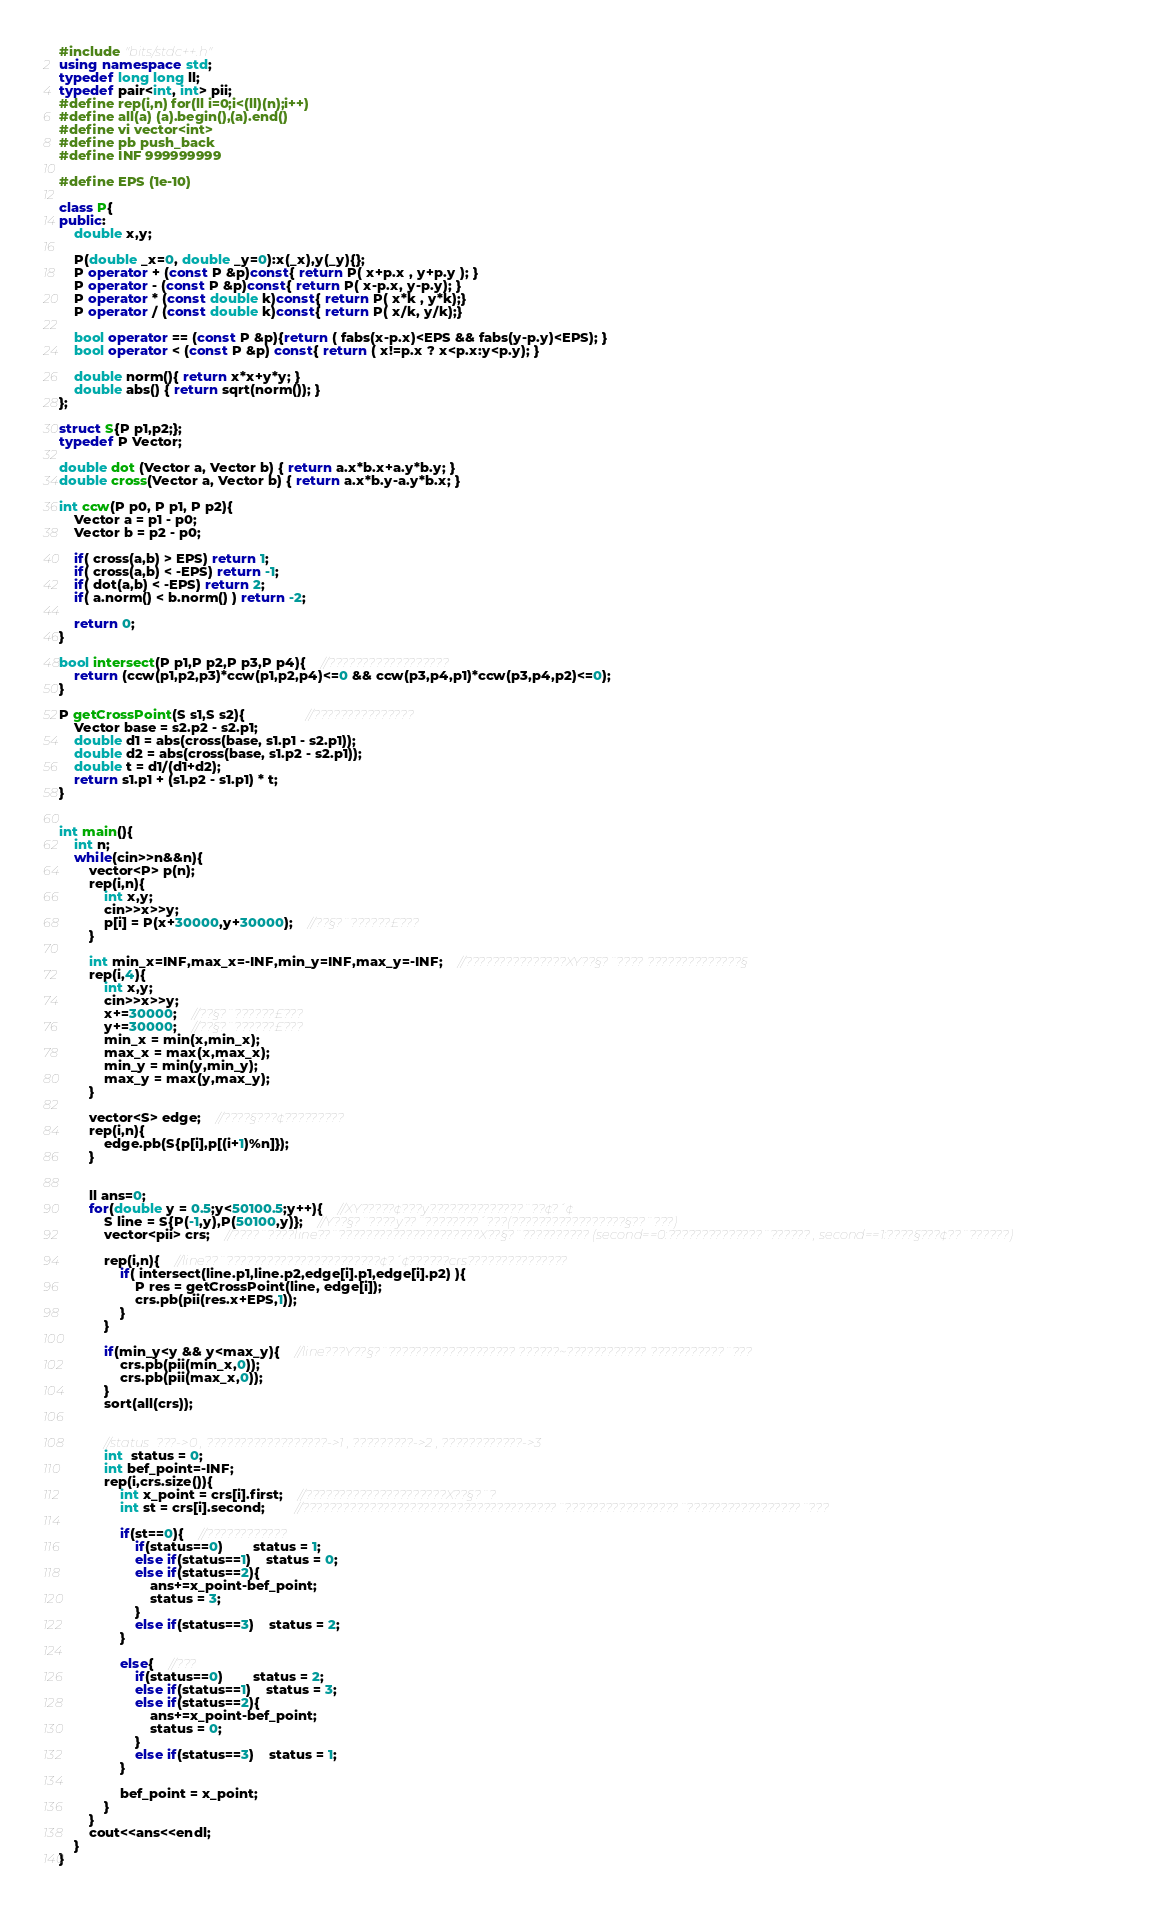<code> <loc_0><loc_0><loc_500><loc_500><_C++_>#include "bits/stdc++.h"
using namespace std;
typedef long long ll;
typedef pair<int, int> pii;
#define rep(i,n) for(ll i=0;i<(ll)(n);i++)
#define all(a) (a).begin(),(a).end()
#define vi vector<int>
#define pb push_back
#define INF 999999999

#define EPS (1e-10)

class P{
public:
	double x,y;
	
	P(double _x=0, double _y=0):x(_x),y(_y){};
	P operator + (const P &p)const{ return P( x+p.x , y+p.y ); }
	P operator - (const P &p)const{ return P( x-p.x, y-p.y); }
	P operator * (const double k)const{ return P( x*k , y*k);}
	P operator / (const double k)const{ return P( x/k, y/k);}
	
	bool operator == (const P &p){return ( fabs(x-p.x)<EPS && fabs(y-p.y)<EPS); }
	bool operator < (const P &p) const{ return ( x!=p.x ? x<p.x:y<p.y); }
	
	double norm(){ return x*x+y*y; }
	double abs() { return sqrt(norm()); }
};

struct S{P p1,p2;};
typedef P Vector;

double dot (Vector a, Vector b) { return a.x*b.x+a.y*b.y; }
double cross(Vector a, Vector b) { return a.x*b.y-a.y*b.x; }

int ccw(P p0, P p1, P p2){
	Vector a = p1 - p0;
	Vector b = p2 - p0;
	
	if( cross(a,b) > EPS) return 1;
	if( cross(a,b) < -EPS) return -1;
	if( dot(a,b) < -EPS) return 2;
	if( a.norm() < b.norm() ) return -2;
	
	return 0;
}

bool intersect(P p1,P p2,P p3,P p4){	//??????????????????
	return (ccw(p1,p2,p3)*ccw(p1,p2,p4)<=0 && ccw(p3,p4,p1)*ccw(p3,p4,p2)<=0);
}

P getCrossPoint(S s1,S s2){				//???????????????
	Vector base = s2.p2 - s2.p1;
	double d1 = abs(cross(base, s1.p1 - s2.p1));
	double d2 = abs(cross(base, s1.p2 - s2.p1));
	double t = d1/(d1+d2);
	return s1.p1 + (s1.p2 - s1.p1) * t;
}


int main(){
	int n;
	while(cin>>n&&n){
		vector<P> p(n);
		rep(i,n){
			int x,y;
			cin>>x>>y;
			p[i] = P(x+30000,y+30000);	//??§?¨??????£???
		}
		
		int min_x=INF,max_x=-INF,min_y=INF,max_y=-INF;	//???????????????XY??§?¨???? ??????????????§
		rep(i,4){
			int x,y;
			cin>>x>>y;
			x+=30000;	//??§?¨??????£???
			y+=30000;	//??§?¨??????£???
			min_x = min(x,min_x);
			max_x = max(x,max_x);
			min_y = min(y,min_y);
			max_y = max(y,max_y);
		}
		
		vector<S> edge;	//????§???¢?????????
		rep(i,n){
			edge.pb(S{p[i],p[(i+1)%n]});
		}
		
		
		ll ans=0;
		for(double y = 0.5;y<50100.5;y++){	//XY?????¢???y??????????????¨??¢?´¢
			S line = S{P(-1,y),P(50100,y)};	//Y??§?¨????y??¨????????´???(?????????????????§??¨???)
			vector<pii> crs;	//????¨????line??¨?????????????????????X??§?¨?????????? (second==0:??????????????¨?????? , second==1:????§???¢??¨??????)
			
			rep(i,n){	//line??¨???????????????????????¢?´¢??????crs???????????????
				if( intersect(line.p1,line.p2,edge[i].p1,edge[i].p2) ){
					P res = getCrossPoint(line, edge[i]);
					crs.pb(pii(res.x+EPS,1));
				}
			}
			
			if(min_y<y && y<max_y){	//line???Y??§?¨??????????????????? ??????~???????????? ???????????¨???
				crs.pb(pii(min_x,0));
				crs.pb(pii(max_x,0));
			}
			sort(all(crs));
			
			
			//status  ???->0 , ??????????????????->1 , ?????????->2 , ????????????->3
			int  status = 0;
			int bef_point=-INF;
			rep(i,crs.size()){
				int x_point = crs[i].first;	//?????????????????????X??§?¨?
				int st = crs[i].second;		//??????????????????????????????????????¨?????????????????¨?????????????????¨???
				
				if(st==0){	//????????????
					if(status==0)		status = 1;
					else if(status==1)	status = 0;
					else if(status==2){
						ans+=x_point-bef_point;
						status = 3;
					}
					else if(status==3)	status = 2;
				}
				
				else{	//???
					if(status==0)		status = 2;
					else if(status==1)	status = 3;
					else if(status==2){
						ans+=x_point-bef_point;
						status = 0;
					}
					else if(status==3)	status = 1;
				}
				
				bef_point = x_point;
			}
		}
		cout<<ans<<endl;
	}
}</code> 